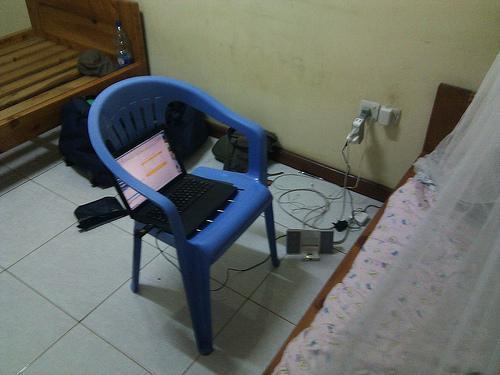How many furniture objects are blue?
Give a very brief answer. 1. 